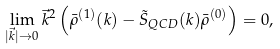Convert formula to latex. <formula><loc_0><loc_0><loc_500><loc_500>\lim _ { | \vec { k } | \rightarrow 0 } \vec { k } ^ { 2 } \left ( \bar { \rho } ^ { ( 1 ) } ( k ) - \tilde { S } _ { Q C D } ( k ) \bar { \rho } ^ { ( 0 ) } \right ) = 0 ,</formula> 